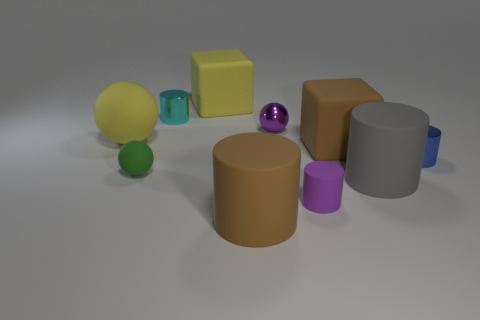There is a yellow thing that is the same shape as the purple shiny object; what is its material?
Offer a terse response. Rubber. What number of big matte objects have the same color as the metal sphere?
Provide a short and direct response. 0. There is a brown cylinder that is made of the same material as the large gray object; what is its size?
Provide a succinct answer. Large. What number of blue objects are either matte cylinders or tiny shiny cylinders?
Offer a very short reply. 1. How many big yellow rubber spheres are in front of the gray matte thing that is behind the large brown cylinder?
Your response must be concise. 0. Is the number of small things that are in front of the brown matte cube greater than the number of gray objects that are right of the small blue object?
Ensure brevity in your answer.  Yes. What is the small blue cylinder made of?
Make the answer very short. Metal. Are there any brown blocks of the same size as the yellow sphere?
Your response must be concise. Yes. There is a purple ball that is the same size as the green rubber thing; what is it made of?
Provide a short and direct response. Metal. What number of tiny metal balls are there?
Offer a terse response. 1. 